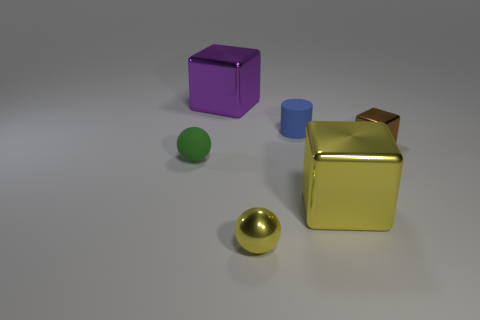The sphere in front of the tiny matte thing that is in front of the brown block is made of what material?
Provide a succinct answer. Metal. There is a blue thing; what shape is it?
Your answer should be very brief. Cylinder. Is the number of small matte objects that are in front of the small green matte thing the same as the number of cubes on the left side of the large yellow block?
Provide a succinct answer. No. There is a large thing that is to the right of the blue thing; does it have the same color as the tiny shiny thing left of the tiny cube?
Make the answer very short. Yes. Are there more metallic blocks in front of the blue rubber object than tiny blue rubber things?
Provide a succinct answer. Yes. What is the shape of the brown thing that is the same material as the purple cube?
Ensure brevity in your answer.  Cube. Do the rubber thing left of the purple object and the yellow cube have the same size?
Your response must be concise. No. There is a large object that is in front of the brown cube that is in front of the small blue object; what is its shape?
Ensure brevity in your answer.  Cube. What is the size of the metal thing behind the small metal object behind the large yellow object?
Ensure brevity in your answer.  Large. There is a cube that is on the left side of the large yellow shiny object; what color is it?
Your response must be concise. Purple. 